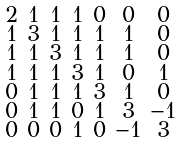Convert formula to latex. <formula><loc_0><loc_0><loc_500><loc_500>\begin{smallmatrix} 2 & 1 & 1 & 1 & 0 & 0 & 0 \\ 1 & 3 & 1 & 1 & 1 & 1 & 0 \\ 1 & 1 & 3 & 1 & 1 & 1 & 0 \\ 1 & 1 & 1 & 3 & 1 & 0 & 1 \\ 0 & 1 & 1 & 1 & 3 & 1 & 0 \\ 0 & 1 & 1 & 0 & 1 & 3 & - 1 \\ 0 & 0 & 0 & 1 & 0 & - 1 & 3 \end{smallmatrix}</formula> 